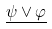<formula> <loc_0><loc_0><loc_500><loc_500>\underline { \psi \vee \varphi }</formula> 